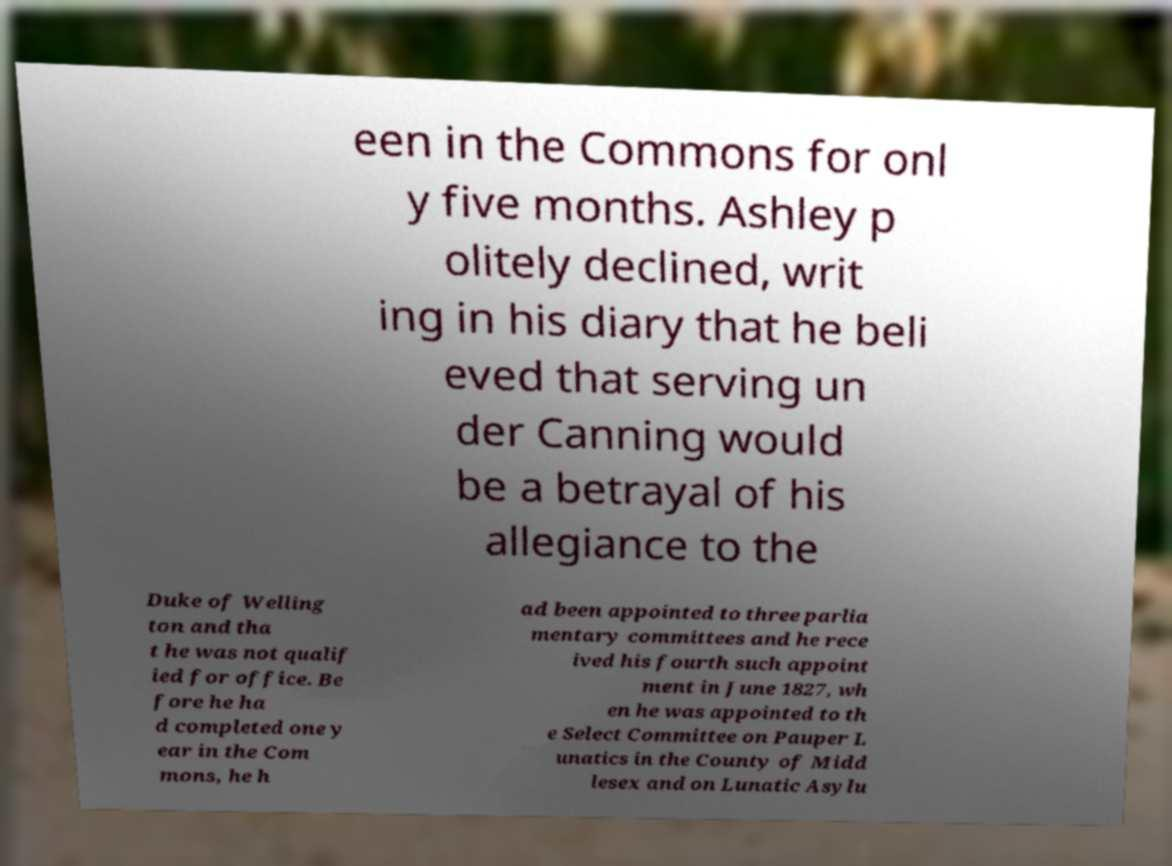Could you extract and type out the text from this image? een in the Commons for onl y five months. Ashley p olitely declined, writ ing in his diary that he beli eved that serving un der Canning would be a betrayal of his allegiance to the Duke of Welling ton and tha t he was not qualif ied for office. Be fore he ha d completed one y ear in the Com mons, he h ad been appointed to three parlia mentary committees and he rece ived his fourth such appoint ment in June 1827, wh en he was appointed to th e Select Committee on Pauper L unatics in the County of Midd lesex and on Lunatic Asylu 